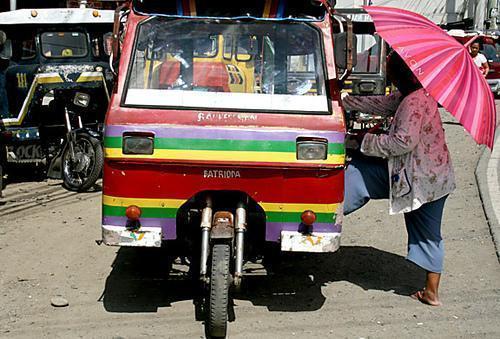What does the front of the automobile shown in this image most resemble?
Indicate the correct choice and explain in the format: 'Answer: answer
Rationale: rationale.'
Options: Rainbow, autumn, circus, sunset. Answer: rainbow.
Rationale: (a) rainbow. the stripes on the front of the auto are similar or the same as the colors you see in a rainbow. What color is at the bottom front of the vehicle in the foreground?
Pick the right solution, then justify: 'Answer: answer
Rationale: rationale.'
Options: Purple, black, blue, red. Answer: purple.
Rationale: Unless you are colorblind you can tell what the color is at the bottom. 